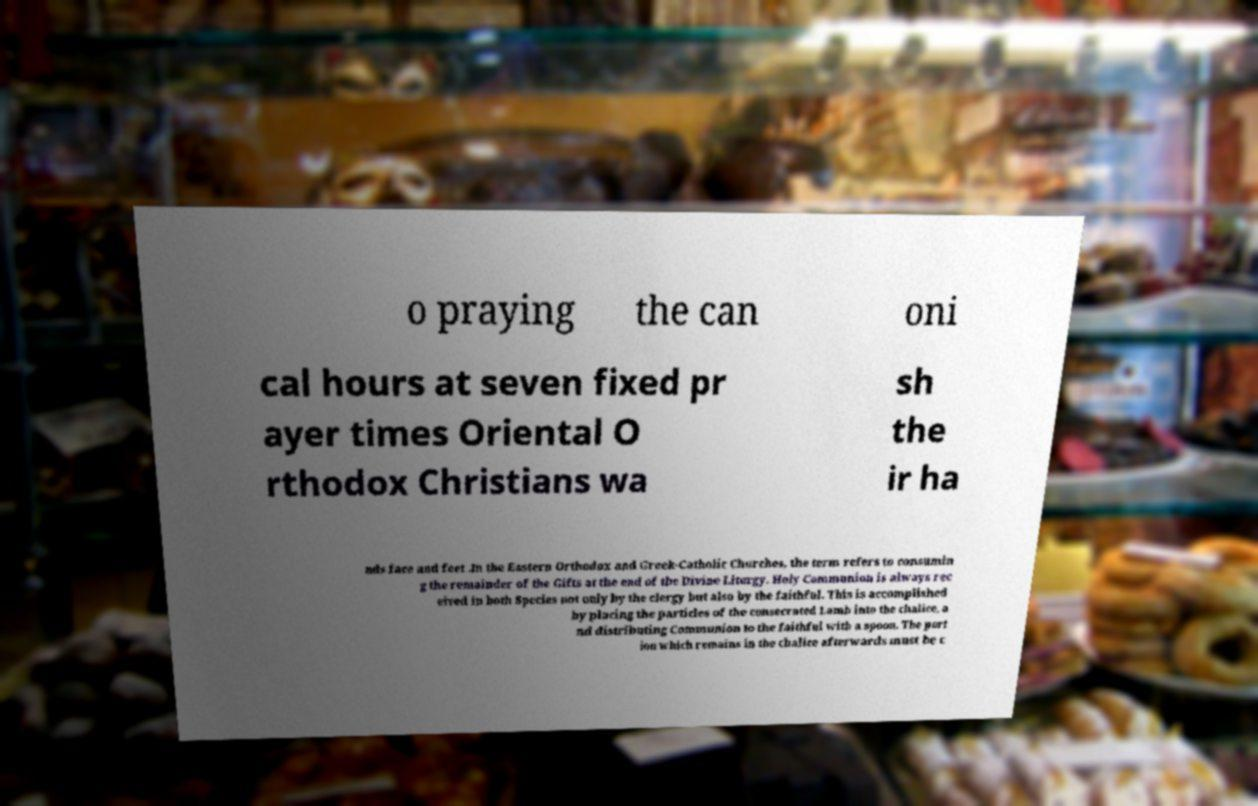There's text embedded in this image that I need extracted. Can you transcribe it verbatim? o praying the can oni cal hours at seven fixed pr ayer times Oriental O rthodox Christians wa sh the ir ha nds face and feet .In the Eastern Orthodox and Greek-Catholic Churches, the term refers to consumin g the remainder of the Gifts at the end of the Divine Liturgy. Holy Communion is always rec eived in both Species not only by the clergy but also by the faithful. This is accomplished by placing the particles of the consecrated Lamb into the chalice, a nd distributing Communion to the faithful with a spoon. The port ion which remains in the chalice afterwards must be c 